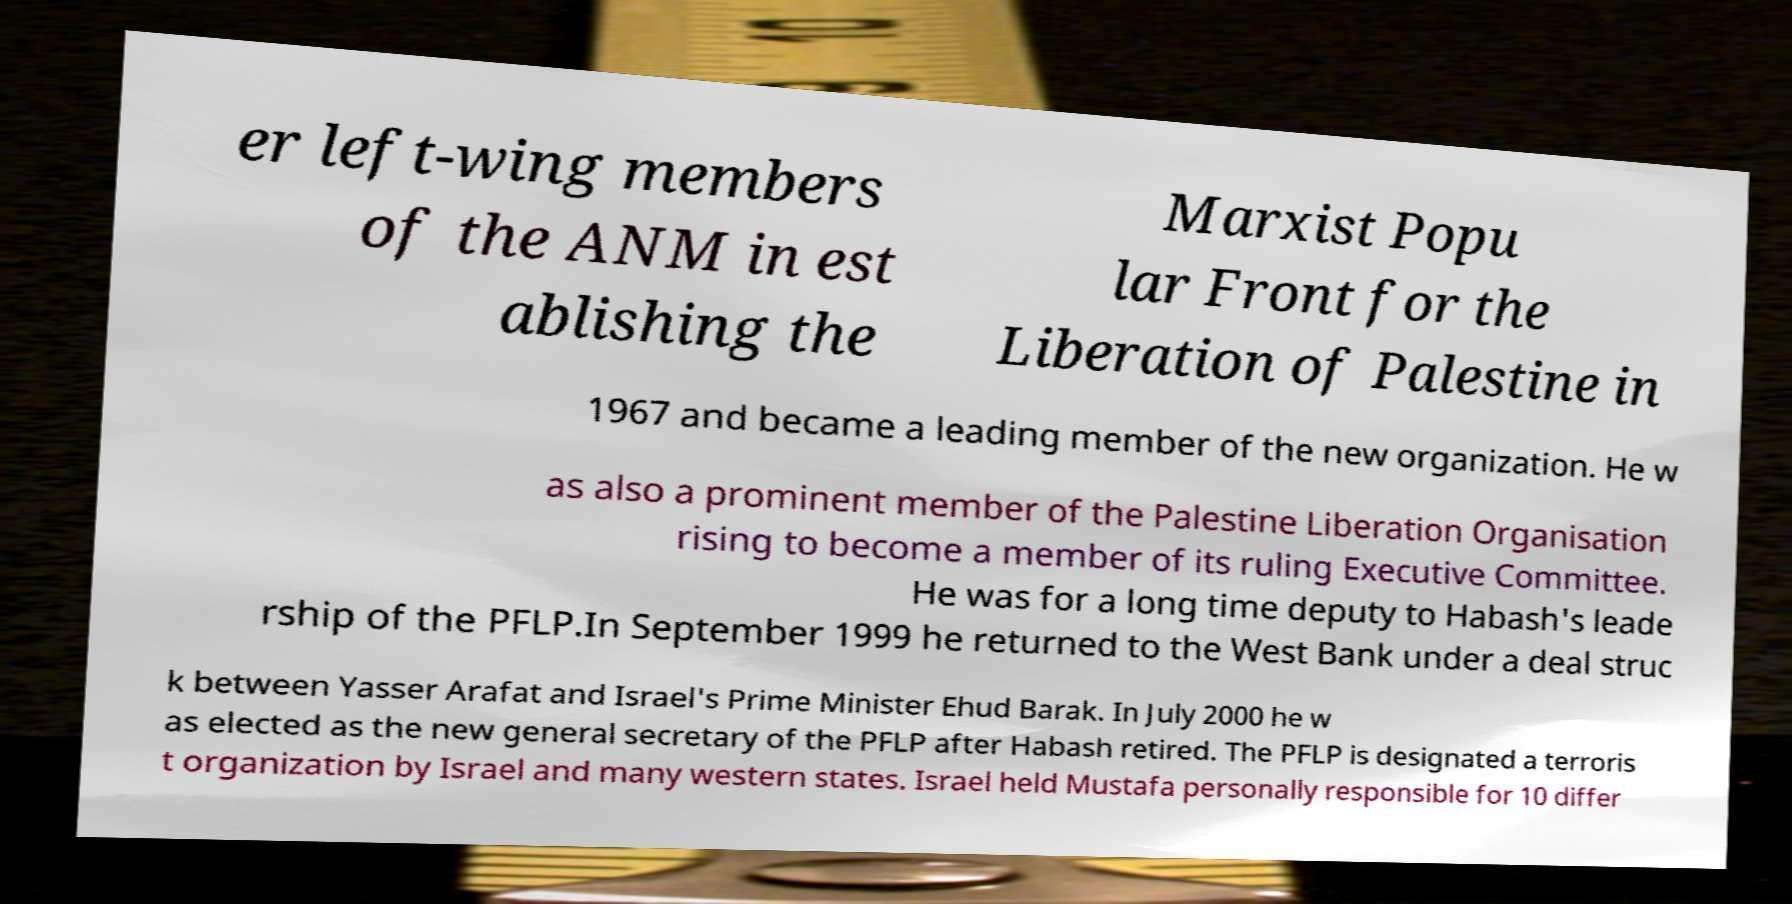There's text embedded in this image that I need extracted. Can you transcribe it verbatim? er left-wing members of the ANM in est ablishing the Marxist Popu lar Front for the Liberation of Palestine in 1967 and became a leading member of the new organization. He w as also a prominent member of the Palestine Liberation Organisation rising to become a member of its ruling Executive Committee. He was for a long time deputy to Habash's leade rship of the PFLP.In September 1999 he returned to the West Bank under a deal struc k between Yasser Arafat and Israel's Prime Minister Ehud Barak. In July 2000 he w as elected as the new general secretary of the PFLP after Habash retired. The PFLP is designated a terroris t organization by Israel and many western states. Israel held Mustafa personally responsible for 10 differ 